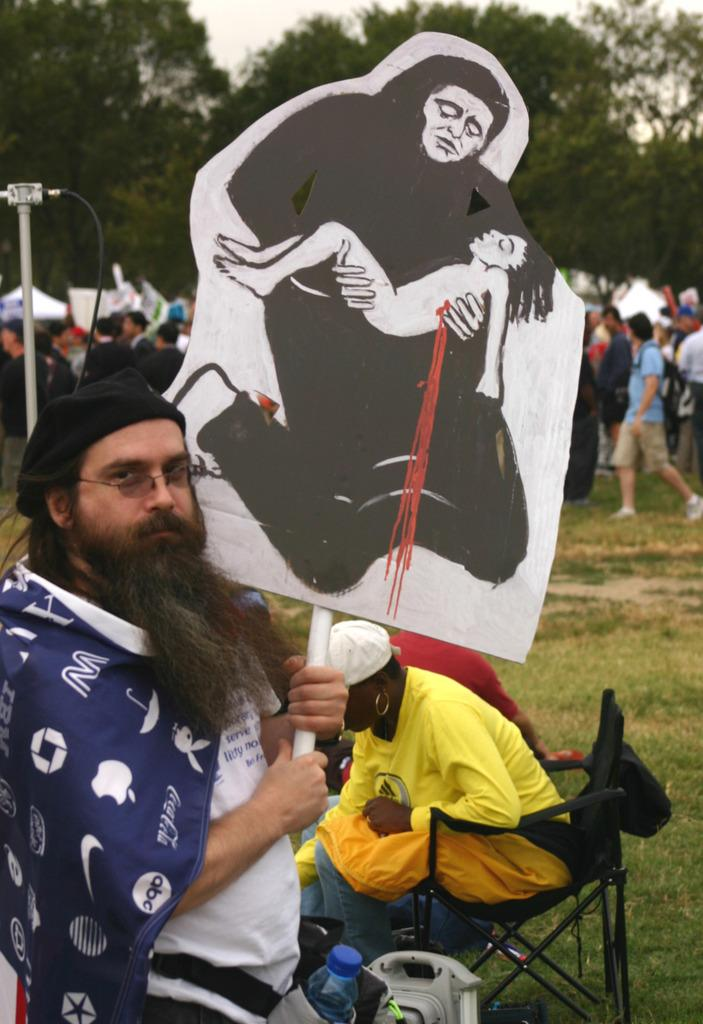Who is present in the image? There is a man in the image. What is the man holding in the image? The man is holding a placard. What else can be seen in the image besides the man and the placard? A: There are sketches in the image. What can be seen in the background of the image? There are trees visible in the background of the image. What type of whip is the man using to create the sketches in the image? There is no whip present in the image, and the man is not creating sketches by using a whip. 